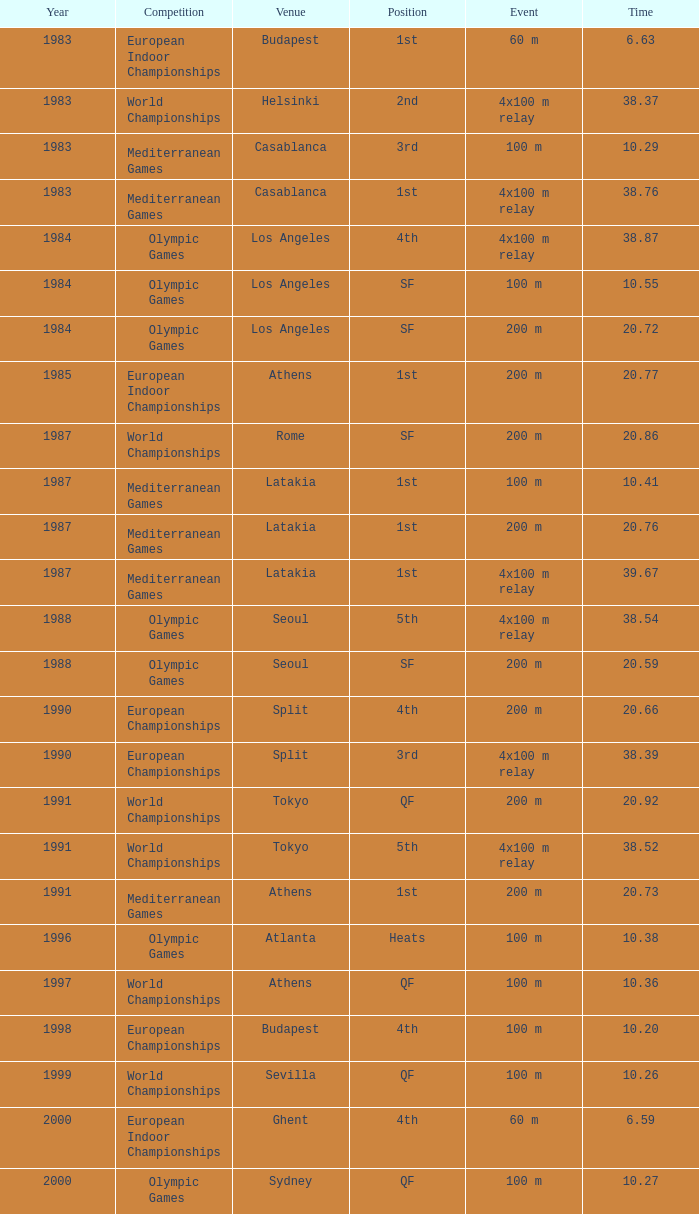What is the top time during 1991 for the 4x100 m relay event? 38.52. 